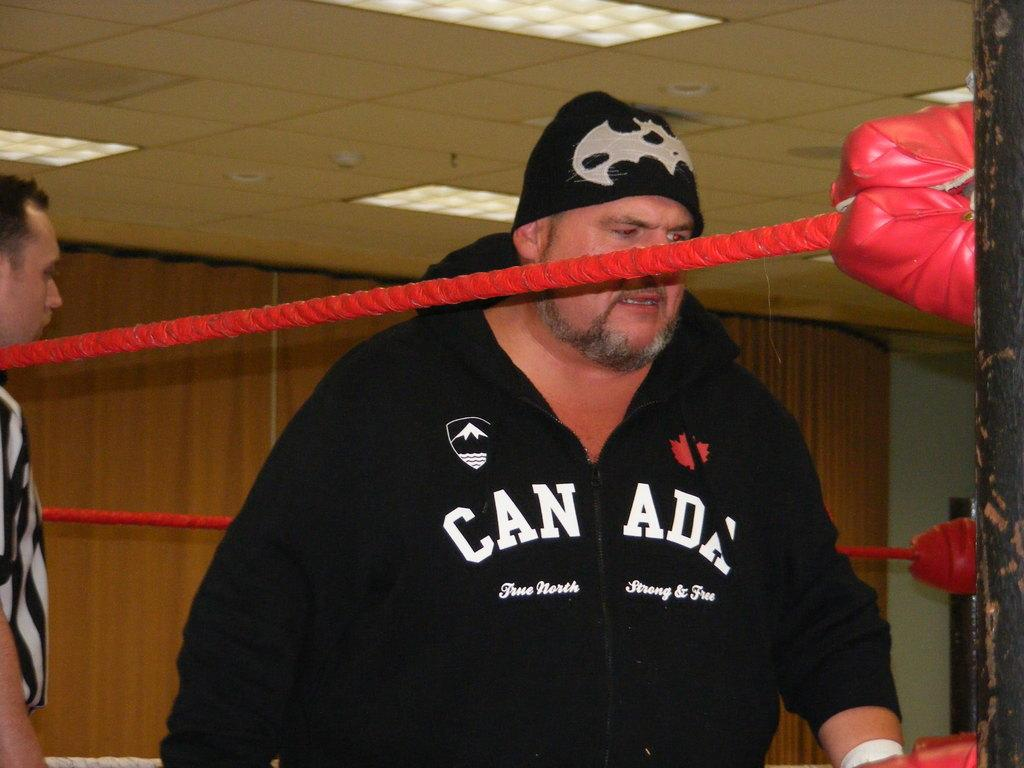<image>
Provide a brief description of the given image. A man wearing a Canada hooded sweatshirt appears fatigued while standing inside of a boxing ring. 